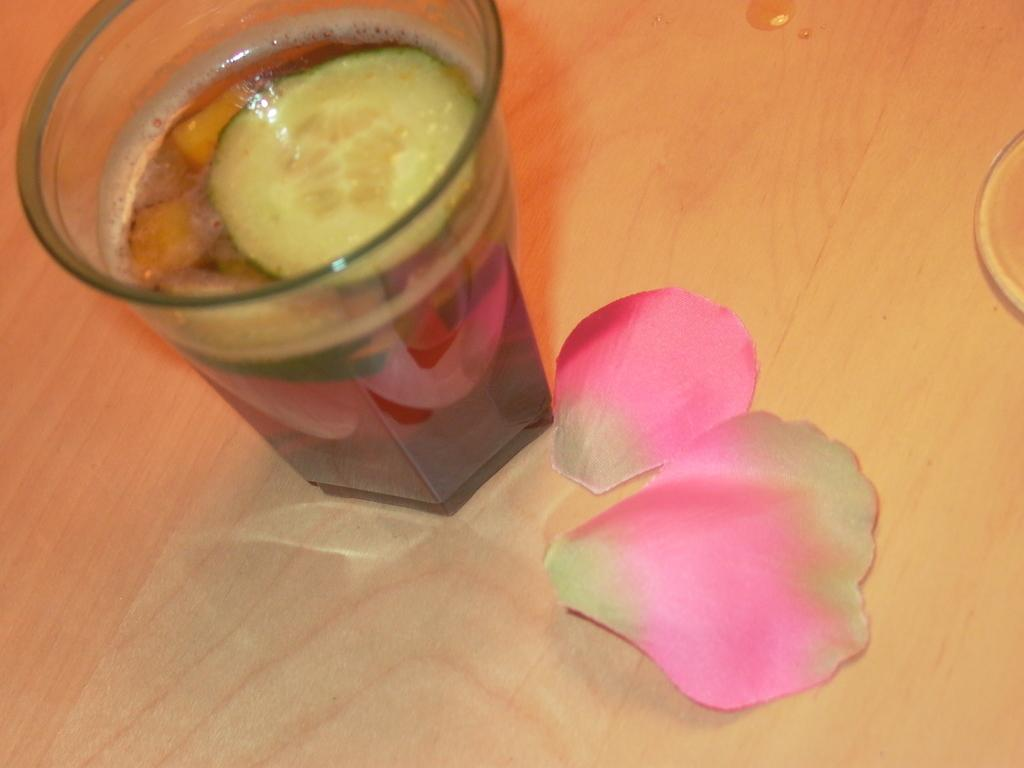What is in the glass that is visible in the image? There is a glass of drink in the image. What other objects can be seen in the image? There are two petals of a flower on the right side of the image. What type of surface is at the bottom of the image? There is a wooden surface at the bottom of the image. What achievement did the stranger accomplish in the image? There is no stranger or achievement present in the image. 